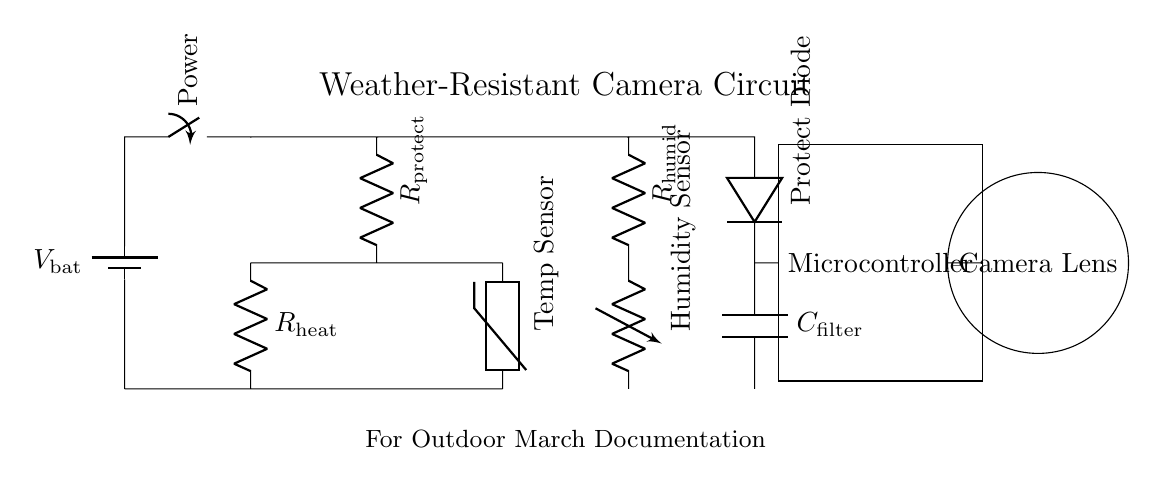What is the main power source in this circuit? The main power source is represented by the battery symbol, labeled as V bat, providing the necessary voltage for the circuit.
Answer: V bat What type of sensor is used in the circuit? The circuit includes a thermistor and a humidity sensor, indicated by their respective symbols and labels in the schematic.
Answer: Thermistor and Humidity Sensor Which component provides protection against overheating? The component that provides protection against overheating is the resistor labeled as R heat, which helps limit the current and protects other components from excess heat.
Answer: R heat How many resistors are present in the circuit? There are three resistors in the circuit: R protect, R heat, and R humid, which are used to manage current and environmental factors.
Answer: Three What is the purpose of the protect diode? The protect diode serves to prevent reverse current that could damage the circuit, allowing current to flow in only one direction.
Answer: Prevents reverse current What will happen if the humidity sensor detects high humidity? If the humidity sensor detects high humidity, it may alter the resistance and signal to the microcontroller, triggering action to protect the camera gear from water damage.
Answer: Signal to microcontroller What is the role of the microcontroller in this circuit? The microcontroller processes data from the sensors (temperature and humidity) to manage the operation of the camera gear, ensuring safe usage in outdoor conditions.
Answer: Manages sensor data 